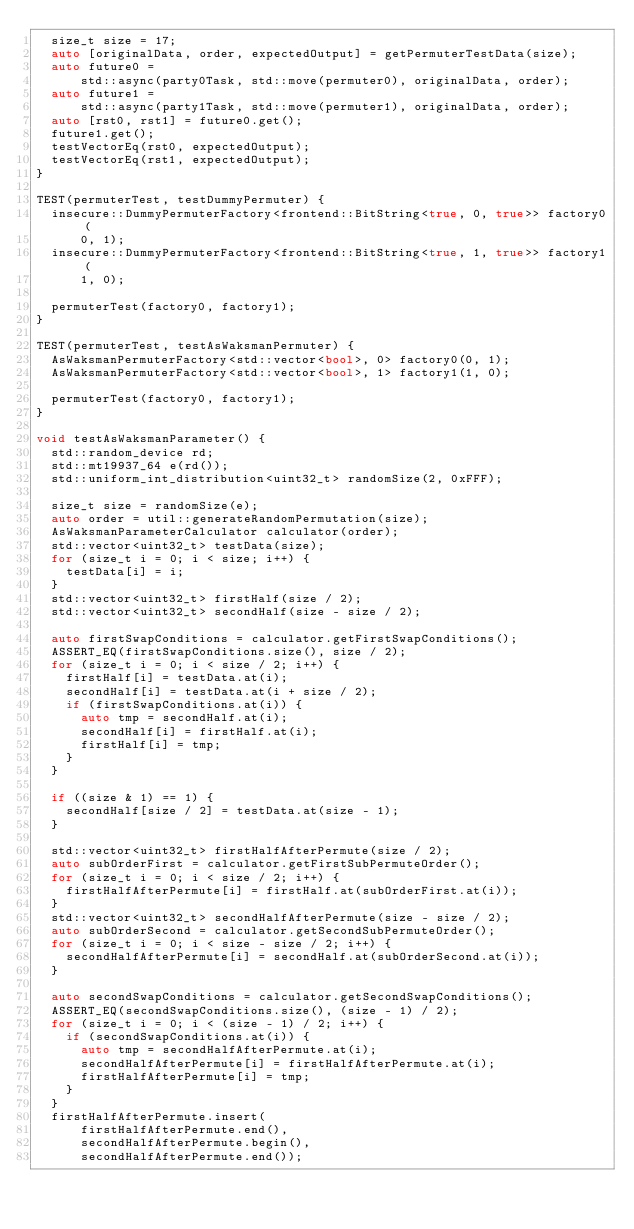<code> <loc_0><loc_0><loc_500><loc_500><_C++_>  size_t size = 17;
  auto [originalData, order, expectedOutput] = getPermuterTestData(size);
  auto future0 =
      std::async(party0Task, std::move(permuter0), originalData, order);
  auto future1 =
      std::async(party1Task, std::move(permuter1), originalData, order);
  auto [rst0, rst1] = future0.get();
  future1.get();
  testVectorEq(rst0, expectedOutput);
  testVectorEq(rst1, expectedOutput);
}

TEST(permuterTest, testDummyPermuter) {
  insecure::DummyPermuterFactory<frontend::BitString<true, 0, true>> factory0(
      0, 1);
  insecure::DummyPermuterFactory<frontend::BitString<true, 1, true>> factory1(
      1, 0);

  permuterTest(factory0, factory1);
}

TEST(permuterTest, testAsWaksmanPermuter) {
  AsWaksmanPermuterFactory<std::vector<bool>, 0> factory0(0, 1);
  AsWaksmanPermuterFactory<std::vector<bool>, 1> factory1(1, 0);

  permuterTest(factory0, factory1);
}

void testAsWaksmanParameter() {
  std::random_device rd;
  std::mt19937_64 e(rd());
  std::uniform_int_distribution<uint32_t> randomSize(2, 0xFFF);

  size_t size = randomSize(e);
  auto order = util::generateRandomPermutation(size);
  AsWaksmanParameterCalculator calculator(order);
  std::vector<uint32_t> testData(size);
  for (size_t i = 0; i < size; i++) {
    testData[i] = i;
  }
  std::vector<uint32_t> firstHalf(size / 2);
  std::vector<uint32_t> secondHalf(size - size / 2);

  auto firstSwapConditions = calculator.getFirstSwapConditions();
  ASSERT_EQ(firstSwapConditions.size(), size / 2);
  for (size_t i = 0; i < size / 2; i++) {
    firstHalf[i] = testData.at(i);
    secondHalf[i] = testData.at(i + size / 2);
    if (firstSwapConditions.at(i)) {
      auto tmp = secondHalf.at(i);
      secondHalf[i] = firstHalf.at(i);
      firstHalf[i] = tmp;
    }
  }

  if ((size & 1) == 1) {
    secondHalf[size / 2] = testData.at(size - 1);
  }

  std::vector<uint32_t> firstHalfAfterPermute(size / 2);
  auto subOrderFirst = calculator.getFirstSubPermuteOrder();
  for (size_t i = 0; i < size / 2; i++) {
    firstHalfAfterPermute[i] = firstHalf.at(subOrderFirst.at(i));
  }
  std::vector<uint32_t> secondHalfAfterPermute(size - size / 2);
  auto subOrderSecond = calculator.getSecondSubPermuteOrder();
  for (size_t i = 0; i < size - size / 2; i++) {
    secondHalfAfterPermute[i] = secondHalf.at(subOrderSecond.at(i));
  }

  auto secondSwapConditions = calculator.getSecondSwapConditions();
  ASSERT_EQ(secondSwapConditions.size(), (size - 1) / 2);
  for (size_t i = 0; i < (size - 1) / 2; i++) {
    if (secondSwapConditions.at(i)) {
      auto tmp = secondHalfAfterPermute.at(i);
      secondHalfAfterPermute[i] = firstHalfAfterPermute.at(i);
      firstHalfAfterPermute[i] = tmp;
    }
  }
  firstHalfAfterPermute.insert(
      firstHalfAfterPermute.end(),
      secondHalfAfterPermute.begin(),
      secondHalfAfterPermute.end());
</code> 